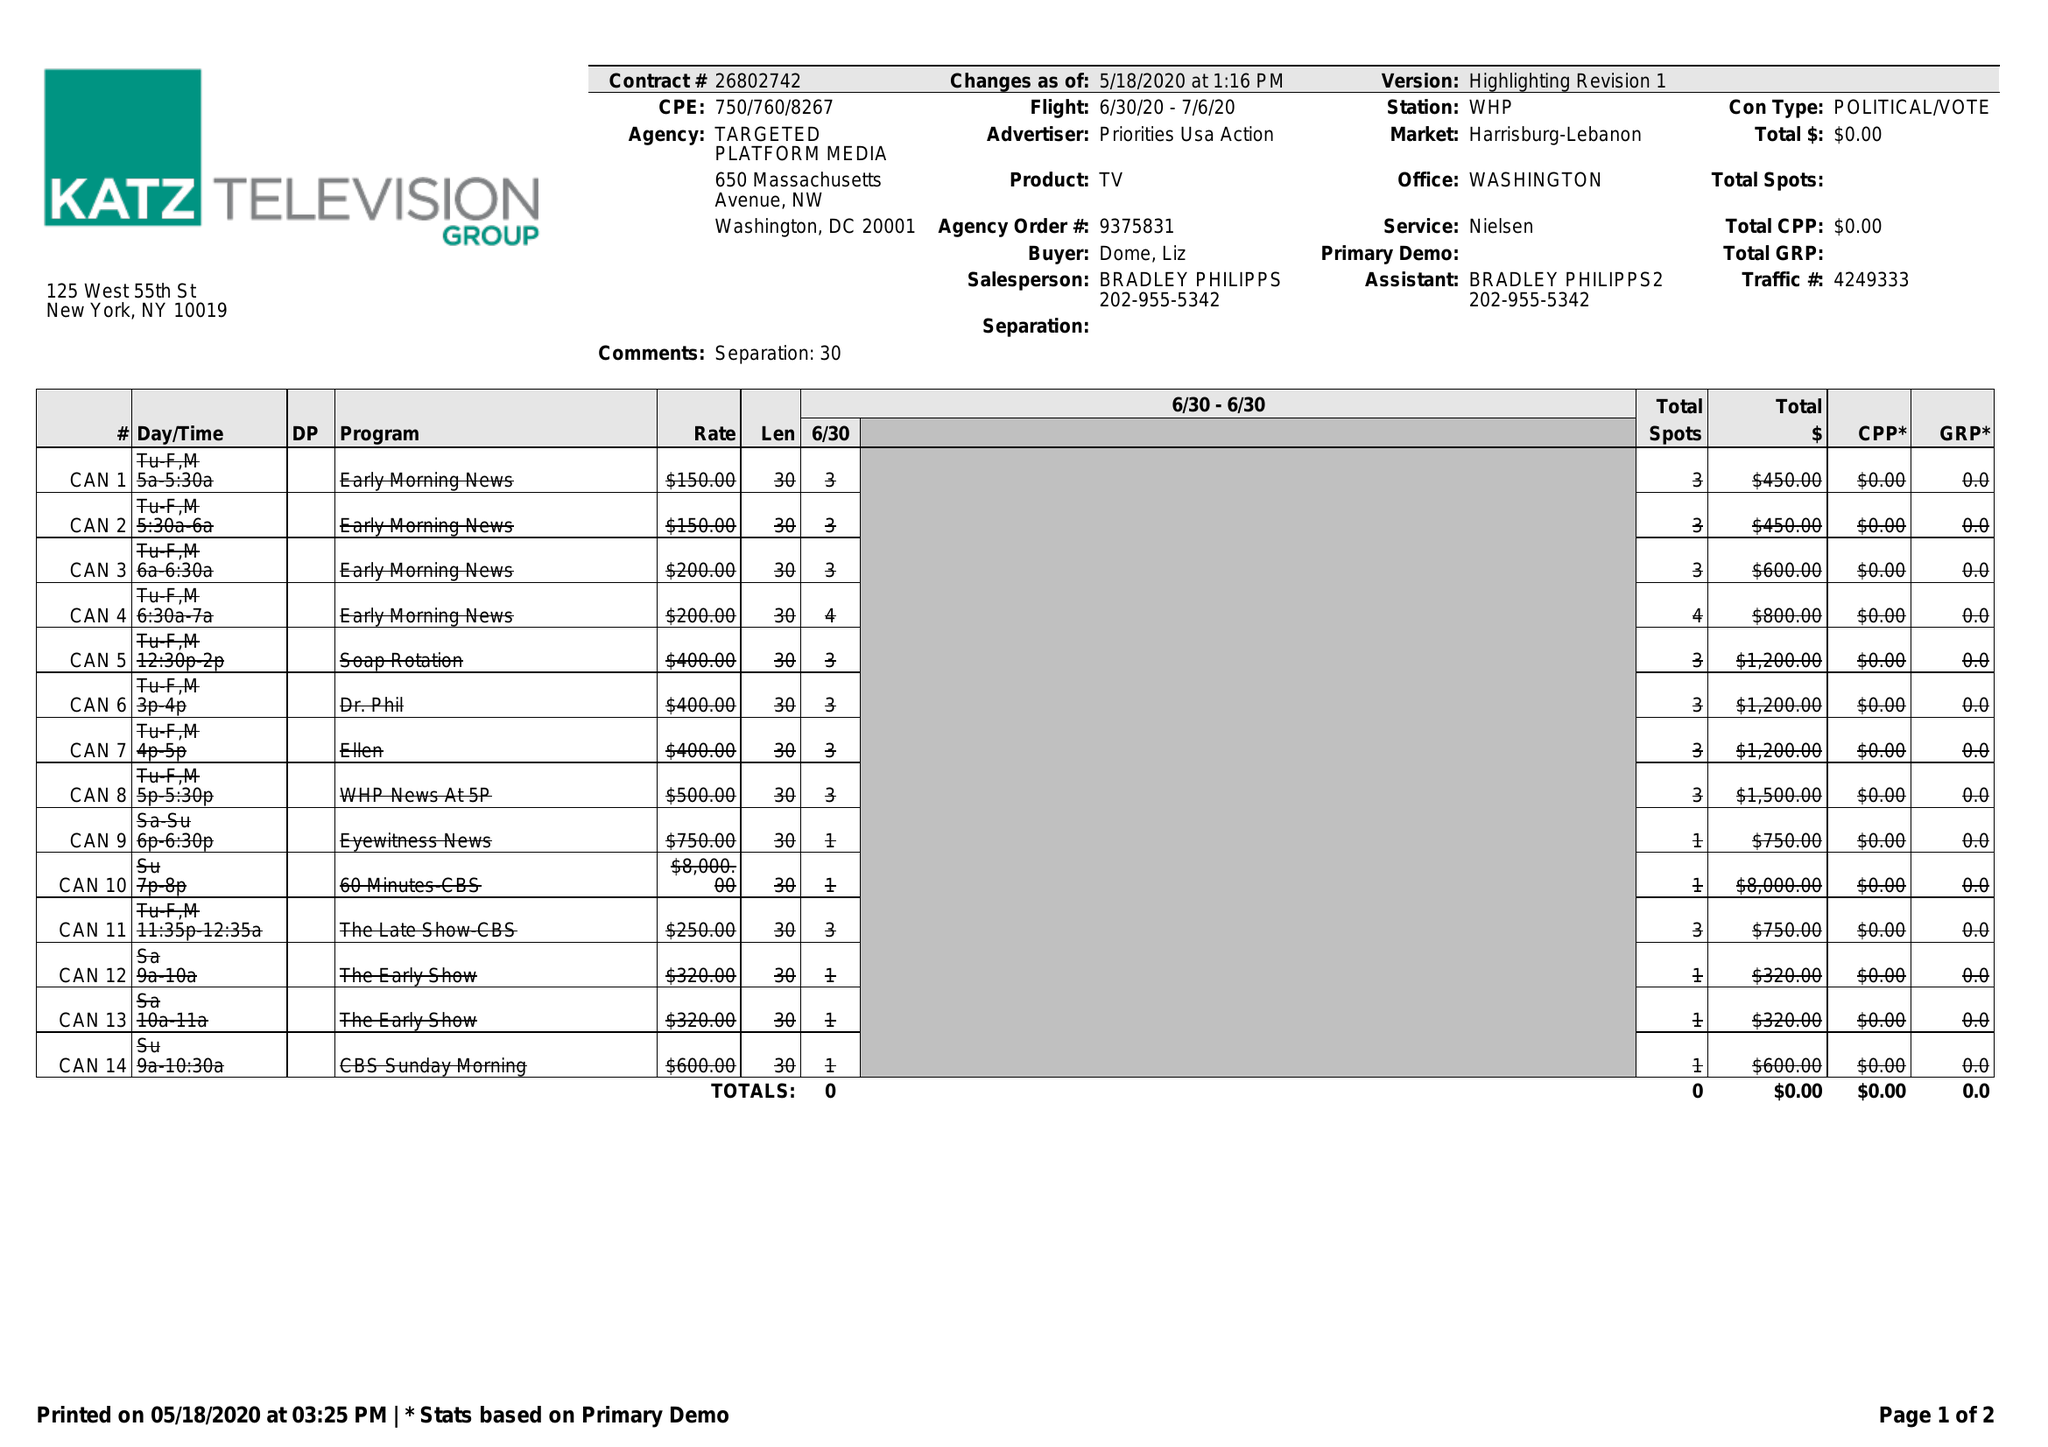What is the value for the contract_num?
Answer the question using a single word or phrase. 26802742 